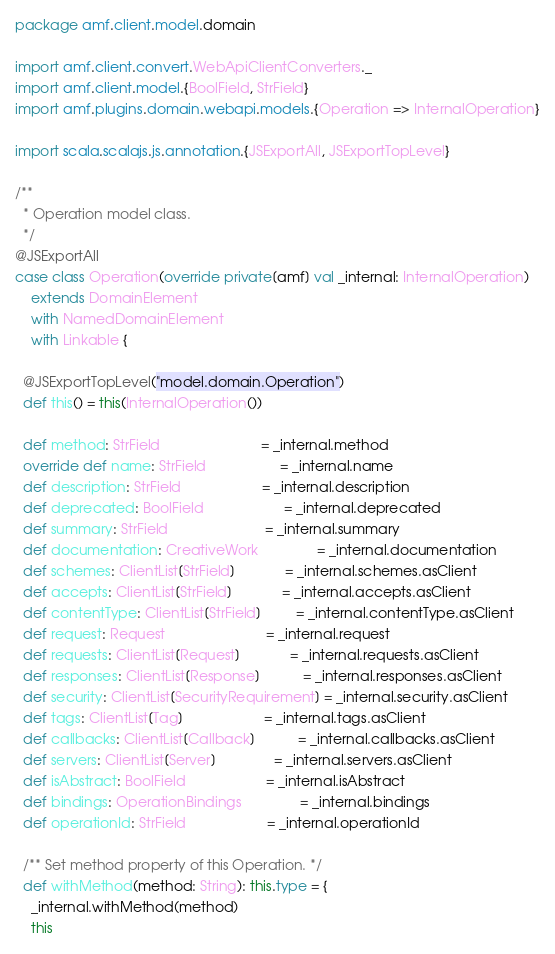<code> <loc_0><loc_0><loc_500><loc_500><_Scala_>package amf.client.model.domain

import amf.client.convert.WebApiClientConverters._
import amf.client.model.{BoolField, StrField}
import amf.plugins.domain.webapi.models.{Operation => InternalOperation}

import scala.scalajs.js.annotation.{JSExportAll, JSExportTopLevel}

/**
  * Operation model class.
  */
@JSExportAll
case class Operation(override private[amf] val _internal: InternalOperation)
    extends DomainElement
    with NamedDomainElement
    with Linkable {

  @JSExportTopLevel("model.domain.Operation")
  def this() = this(InternalOperation())

  def method: StrField                          = _internal.method
  override def name: StrField                   = _internal.name
  def description: StrField                     = _internal.description
  def deprecated: BoolField                     = _internal.deprecated
  def summary: StrField                         = _internal.summary
  def documentation: CreativeWork               = _internal.documentation
  def schemes: ClientList[StrField]             = _internal.schemes.asClient
  def accepts: ClientList[StrField]             = _internal.accepts.asClient
  def contentType: ClientList[StrField]         = _internal.contentType.asClient
  def request: Request                          = _internal.request
  def requests: ClientList[Request]             = _internal.requests.asClient
  def responses: ClientList[Response]           = _internal.responses.asClient
  def security: ClientList[SecurityRequirement] = _internal.security.asClient
  def tags: ClientList[Tag]                     = _internal.tags.asClient
  def callbacks: ClientList[Callback]           = _internal.callbacks.asClient
  def servers: ClientList[Server]               = _internal.servers.asClient
  def isAbstract: BoolField                     = _internal.isAbstract
  def bindings: OperationBindings               = _internal.bindings
  def operationId: StrField                     = _internal.operationId

  /** Set method property of this Operation. */
  def withMethod(method: String): this.type = {
    _internal.withMethod(method)
    this</code> 